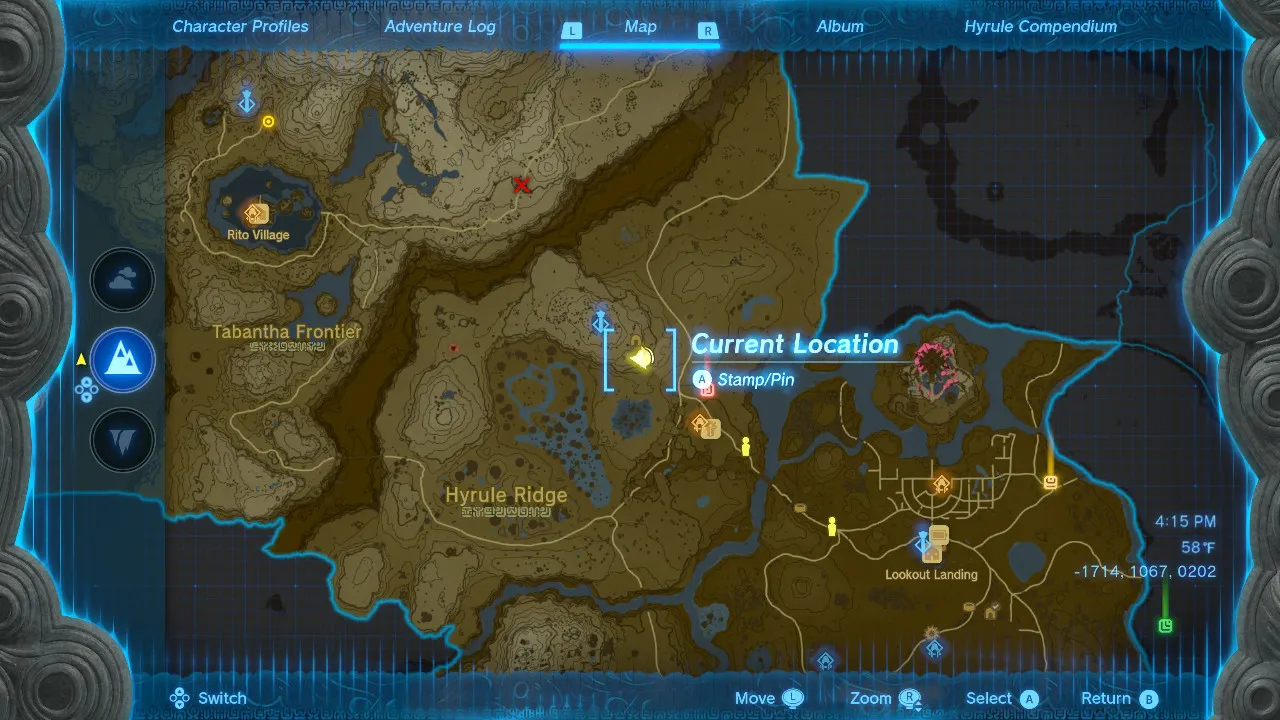Given my horse's location on this map, what is the quickest route to reach it? This is an image of the in-game map from "The Legend of Zelda: Breath of the Wild." To reach your horse from your current location on the map, you should consider the following steps:

1. Look for any nearby landmarks, roads, or paths that lead in the general direction of your horse's icon. In-game paths are usually the safest and sometimes the fastest way to travel.

2. Since the horse's icon appears to be to the east of your current location, you should start by heading eastward, following any paths or natural terrain that lead in that direction.

3. Avoid obstacles such as mountains or bodies of water that might require a detour unless you have the necessary equipment or abilities to traverse them efficiently (like climbing gear or the ability to glide).

4. If you have the ability to fast travel to a nearby shrine or tower that is closer to your horse, this could significantly reduce your travel time. After fast traveling, you can then make your way to your horse from the new location.

5. Ensure your character is equipped for the journey, as you may encounter enemies or harsh environmental conditions along the way.

Remember that "Breath of the Wild" is an open-world game, so there are often multiple paths to the same destination. The quickest route can vary depending on your character's abilities, the equipment you have, and the environmental challenges you're willing to face. 